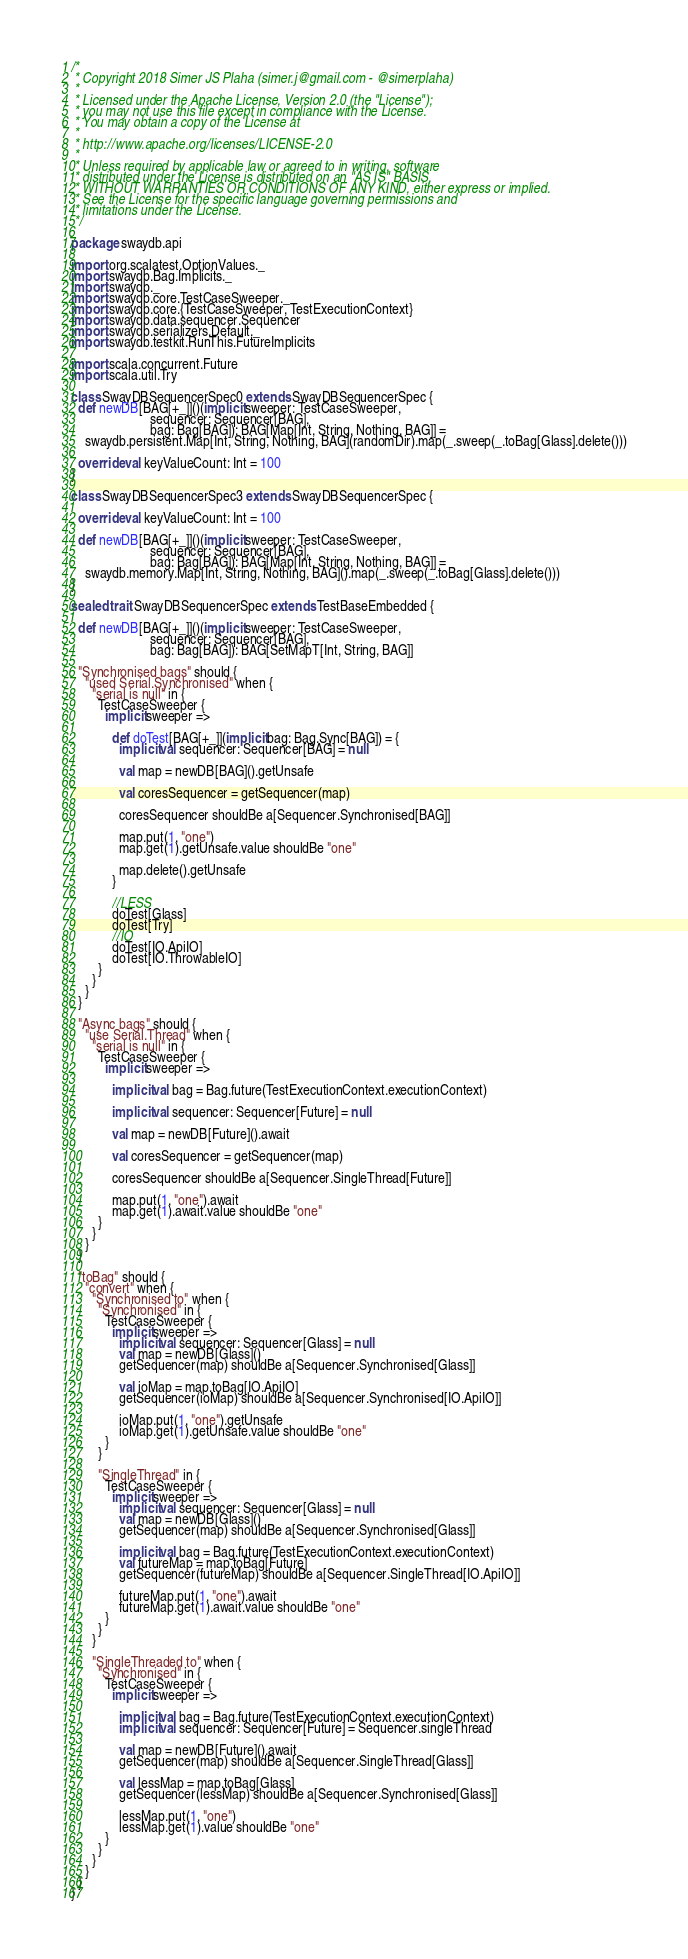Convert code to text. <code><loc_0><loc_0><loc_500><loc_500><_Scala_>/*
 * Copyright 2018 Simer JS Plaha (simer.j@gmail.com - @simerplaha)
 *
 * Licensed under the Apache License, Version 2.0 (the "License");
 * you may not use this file except in compliance with the License.
 * You may obtain a copy of the License at
 *
 * http://www.apache.org/licenses/LICENSE-2.0
 *
 * Unless required by applicable law or agreed to in writing, software
 * distributed under the License is distributed on an "AS IS" BASIS,
 * WITHOUT WARRANTIES OR CONDITIONS OF ANY KIND, either express or implied.
 * See the License for the specific language governing permissions and
 * limitations under the License.
 */

package swaydb.api

import org.scalatest.OptionValues._
import swaydb.Bag.Implicits._
import swaydb._
import swaydb.core.TestCaseSweeper._
import swaydb.core.{TestCaseSweeper, TestExecutionContext}
import swaydb.data.sequencer.Sequencer
import swaydb.serializers.Default._
import swaydb.testkit.RunThis.FutureImplicits

import scala.concurrent.Future
import scala.util.Try

class SwayDBSequencerSpec0 extends SwayDBSequencerSpec {
  def newDB[BAG[+_]]()(implicit sweeper: TestCaseSweeper,
                       sequencer: Sequencer[BAG],
                       bag: Bag[BAG]): BAG[Map[Int, String, Nothing, BAG]] =
    swaydb.persistent.Map[Int, String, Nothing, BAG](randomDir).map(_.sweep(_.toBag[Glass].delete()))

  override val keyValueCount: Int = 100
}

class SwayDBSequencerSpec3 extends SwayDBSequencerSpec {

  override val keyValueCount: Int = 100

  def newDB[BAG[+_]]()(implicit sweeper: TestCaseSweeper,
                       sequencer: Sequencer[BAG],
                       bag: Bag[BAG]): BAG[Map[Int, String, Nothing, BAG]] =
    swaydb.memory.Map[Int, String, Nothing, BAG]().map(_.sweep(_.toBag[Glass].delete()))
}

sealed trait SwayDBSequencerSpec extends TestBaseEmbedded {

  def newDB[BAG[+_]]()(implicit sweeper: TestCaseSweeper,
                       sequencer: Sequencer[BAG],
                       bag: Bag[BAG]): BAG[SetMapT[Int, String, BAG]]

  "Synchronised bags" should {
    "used Serial.Synchronised" when {
      "serial is null" in {
        TestCaseSweeper {
          implicit sweeper =>

            def doTest[BAG[+_]](implicit bag: Bag.Sync[BAG]) = {
              implicit val sequencer: Sequencer[BAG] = null

              val map = newDB[BAG]().getUnsafe

              val coresSequencer = getSequencer(map)

              coresSequencer shouldBe a[Sequencer.Synchronised[BAG]]

              map.put(1, "one")
              map.get(1).getUnsafe.value shouldBe "one"

              map.delete().getUnsafe
            }

            //LESS
            doTest[Glass]
            doTest[Try]
            //IO
            doTest[IO.ApiIO]
            doTest[IO.ThrowableIO]
        }
      }
    }
  }

  "Async bags" should {
    "use Serial.Thread" when {
      "serial is null" in {
        TestCaseSweeper {
          implicit sweeper =>

            implicit val bag = Bag.future(TestExecutionContext.executionContext)

            implicit val sequencer: Sequencer[Future] = null

            val map = newDB[Future]().await

            val coresSequencer = getSequencer(map)

            coresSequencer shouldBe a[Sequencer.SingleThread[Future]]

            map.put(1, "one").await
            map.get(1).await.value shouldBe "one"
        }
      }
    }
  }

  "toBag" should {
    "convert" when {
      "Synchronised to" when {
        "Synchronised" in {
          TestCaseSweeper {
            implicit sweeper =>
              implicit val sequencer: Sequencer[Glass] = null
              val map = newDB[Glass]()
              getSequencer(map) shouldBe a[Sequencer.Synchronised[Glass]]

              val ioMap = map.toBag[IO.ApiIO]
              getSequencer(ioMap) shouldBe a[Sequencer.Synchronised[IO.ApiIO]]

              ioMap.put(1, "one").getUnsafe
              ioMap.get(1).getUnsafe.value shouldBe "one"
          }
        }

        "SingleThread" in {
          TestCaseSweeper {
            implicit sweeper =>
              implicit val sequencer: Sequencer[Glass] = null
              val map = newDB[Glass]()
              getSequencer(map) shouldBe a[Sequencer.Synchronised[Glass]]

              implicit val bag = Bag.future(TestExecutionContext.executionContext)
              val futureMap = map.toBag[Future]
              getSequencer(futureMap) shouldBe a[Sequencer.SingleThread[IO.ApiIO]]

              futureMap.put(1, "one").await
              futureMap.get(1).await.value shouldBe "one"
          }
        }
      }

      "SingleThreaded to" when {
        "Synchronised" in {
          TestCaseSweeper {
            implicit sweeper =>

              implicit val bag = Bag.future(TestExecutionContext.executionContext)
              implicit val sequencer: Sequencer[Future] = Sequencer.singleThread

              val map = newDB[Future]().await
              getSequencer(map) shouldBe a[Sequencer.SingleThread[Glass]]

              val lessMap = map.toBag[Glass]
              getSequencer(lessMap) shouldBe a[Sequencer.Synchronised[Glass]]

              lessMap.put(1, "one")
              lessMap.get(1).value shouldBe "one"
          }
        }
      }
    }
  }
}
</code> 